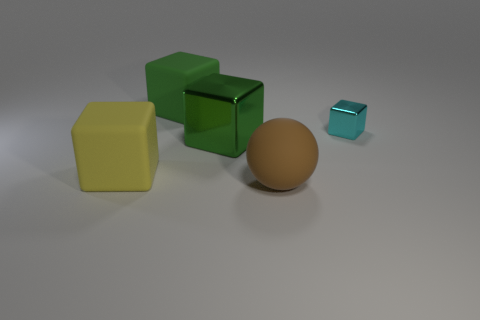Which objects in the image are reflective? In the image, the green cube near the center exhibits a reflective surface, contrasting with the other objects that display matte finishes. 